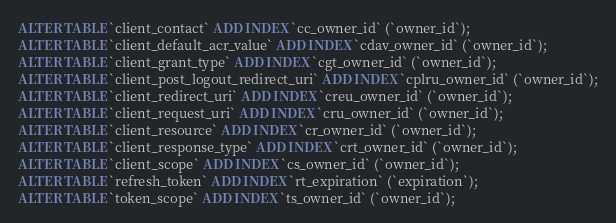<code> <loc_0><loc_0><loc_500><loc_500><_SQL_>ALTER TABLE `client_contact` ADD INDEX `cc_owner_id` (`owner_id`);
ALTER TABLE `client_default_acr_value` ADD INDEX `cdav_owner_id` (`owner_id`);
ALTER TABLE `client_grant_type` ADD INDEX `cgt_owner_id` (`owner_id`);
ALTER TABLE `client_post_logout_redirect_uri` ADD INDEX `cplru_owner_id` (`owner_id`);
ALTER TABLE `client_redirect_uri` ADD INDEX `creu_owner_id` (`owner_id`);
ALTER TABLE `client_request_uri` ADD INDEX `cru_owner_id` (`owner_id`);
ALTER TABLE `client_resource` ADD INDEX `cr_owner_id` (`owner_id`);
ALTER TABLE `client_response_type` ADD INDEX `crt_owner_id` (`owner_id`);
ALTER TABLE `client_scope` ADD INDEX `cs_owner_id` (`owner_id`);
ALTER TABLE `refresh_token` ADD INDEX `rt_expiration` (`expiration`);
ALTER TABLE `token_scope` ADD INDEX `ts_owner_id` (`owner_id`);</code> 